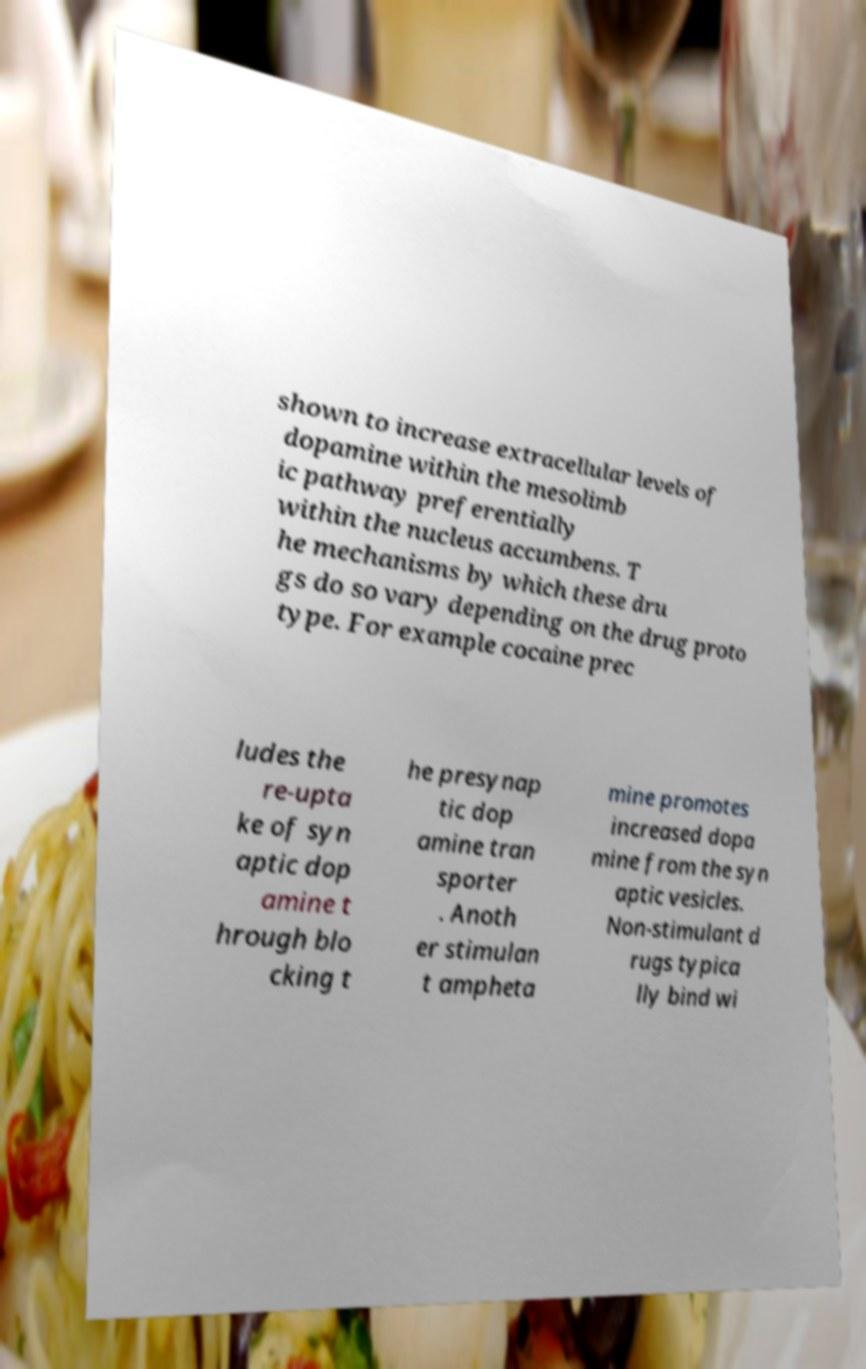I need the written content from this picture converted into text. Can you do that? shown to increase extracellular levels of dopamine within the mesolimb ic pathway preferentially within the nucleus accumbens. T he mechanisms by which these dru gs do so vary depending on the drug proto type. For example cocaine prec ludes the re-upta ke of syn aptic dop amine t hrough blo cking t he presynap tic dop amine tran sporter . Anoth er stimulan t ampheta mine promotes increased dopa mine from the syn aptic vesicles. Non-stimulant d rugs typica lly bind wi 